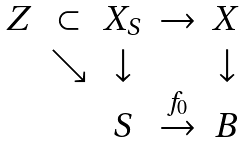<formula> <loc_0><loc_0><loc_500><loc_500>\begin{matrix} Z & \subset & X _ { S } & \to & X \\ & \searrow & \downarrow & & \downarrow \\ & & S & \stackrel { f _ { 0 } } { \to } & B \end{matrix}</formula> 